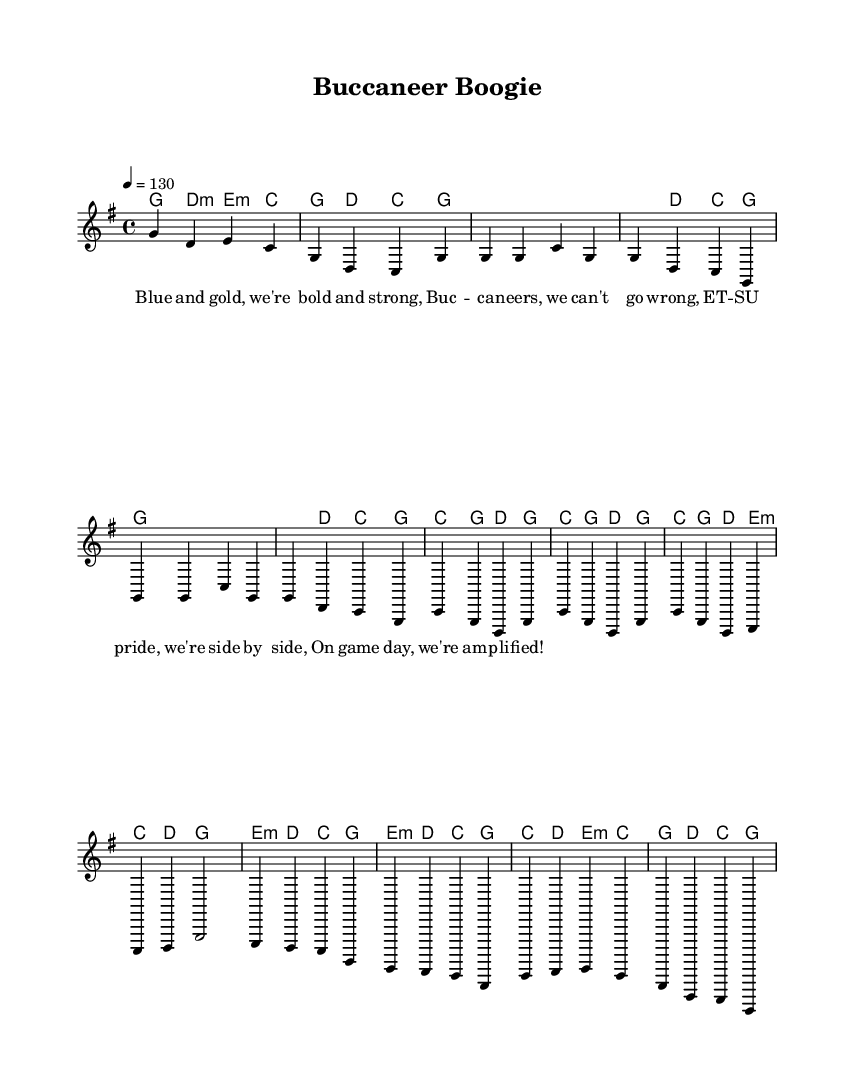What is the key signature of this music? The key signature indicates G major, which has one sharp (F#). This can be determined by looking at the key signature notated at the beginning of the staff.
Answer: G major What is the time signature of this music? The time signature is located at the start of the piece, showing a 4/4 configuration. This means there are four beats in each measure.
Answer: 4/4 What is the tempo marking of this music? The tempo marking is indicated as "4 = 130," which suggests that there are 130 beats per minute. This is found written near the beginning of the score, guiding the pace of the performance.
Answer: 130 List the first word of the lyrics. The lyrics are presented below the melody staff. The first word of the lyrics is found in the first measure of the verses.
Answer: Blue How many measures are there in the chorus? To find the number of measures in the chorus, you can count the measures specifically labeled as the chorus section, starting with the first measure of the chorus until it concludes. There are four measures in total in this section.
Answer: 4 What chord is played during the bridge's first measure? Looking at the chord symbols above the melody during the bridge section will show the specific chords played. The first chord in the bridge is E minor.
Answer: e minor Identify the key change in the song. Throughout the song, the key remains in G major, with no specified key changes. By analyzing each section, including the verse and chorus, you can conclude that the song maintains its original key.
Answer: No key change 